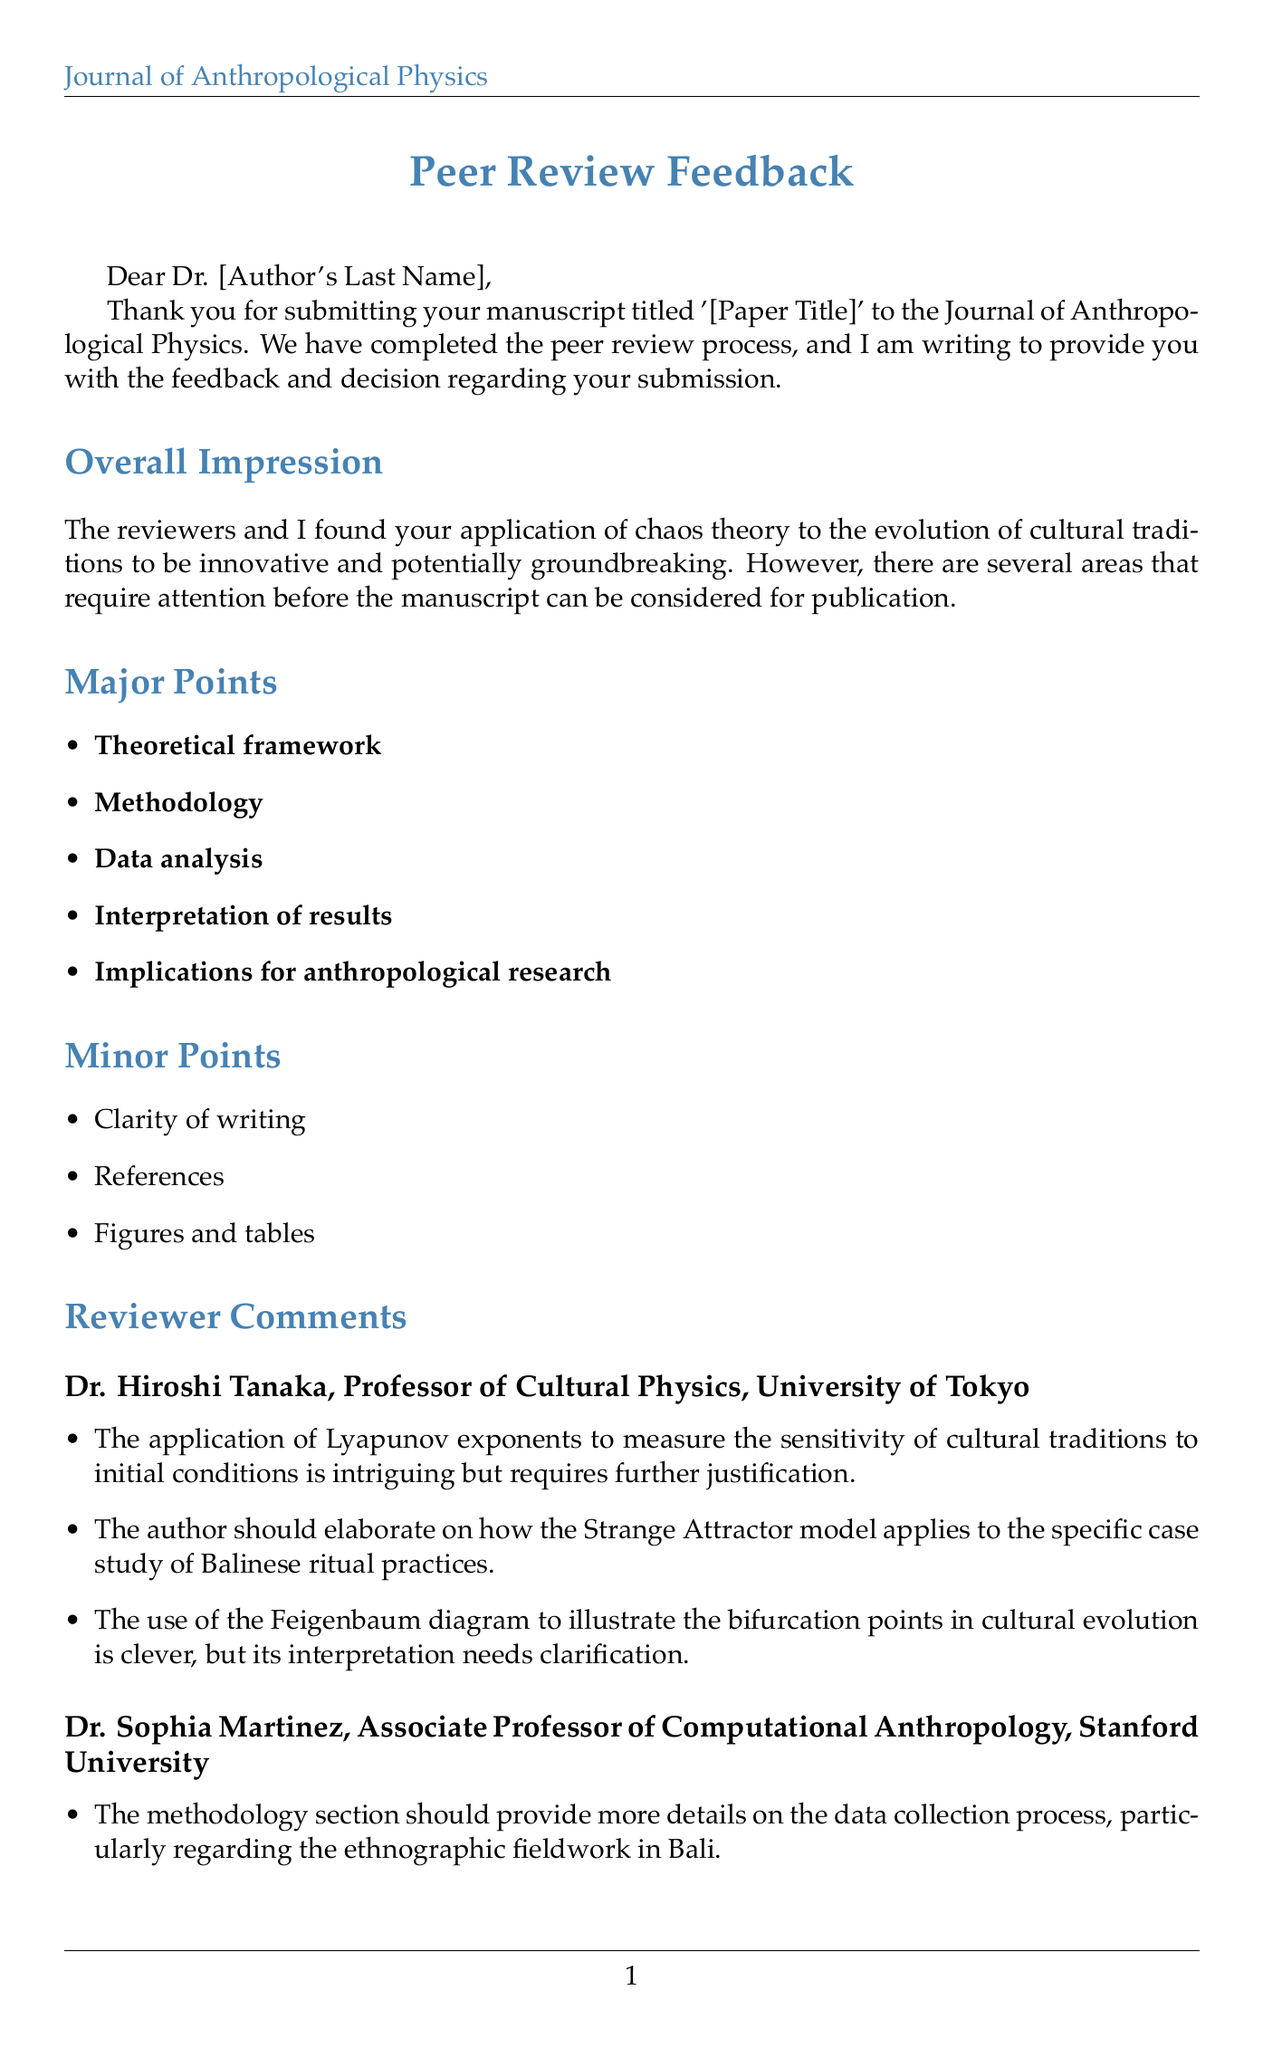what is the title of the manuscript? The title of the manuscript, as provided in the letter, is noted as '[Paper Title]'.
Answer: [Paper Title] who is the Associate Editor of the Journal of Anthropological Physics? The signature section of the letter indicates that Dr. Amelia Cortez is the Associate Editor.
Answer: Dr. Amelia Cortez how many major points are listed in the document? The section titled 'Major Points' lists five specific points that require attention.
Answer: 5 which reviewer commented on the methodology section? The methodology section is mentioned in the comments from Dr. Sophia Martinez.
Answer: Dr. Sophia Martinez what is one of the technical suggestions given to the author? The letter suggests considering using the 0-1 test for chaos to quantify chaotic behavior in cultural evolution.
Answer: 0-1 test for chaos what kind of practices should be represented accurately according to ethical considerations? The letter specifies that the cultural practices of the Balinese community must be represented respectfully and accurately.
Answer: Balinese community how many references are suggested in the document? The 'Suggested References' section contains four references that are listed for the author to consider.
Answer: 4 what does the overall impression section emphasize about the manuscript? The overall impression highlights that the application of chaos theory to cultural traditions is innovative and potentially groundbreaking.
Answer: innovative and potentially groundbreaking what is required for resubmission of the manuscript? Along with the revised manuscript, the author is asked to include a point-by-point response to the reviewers' comments.
Answer: point-by-point response 